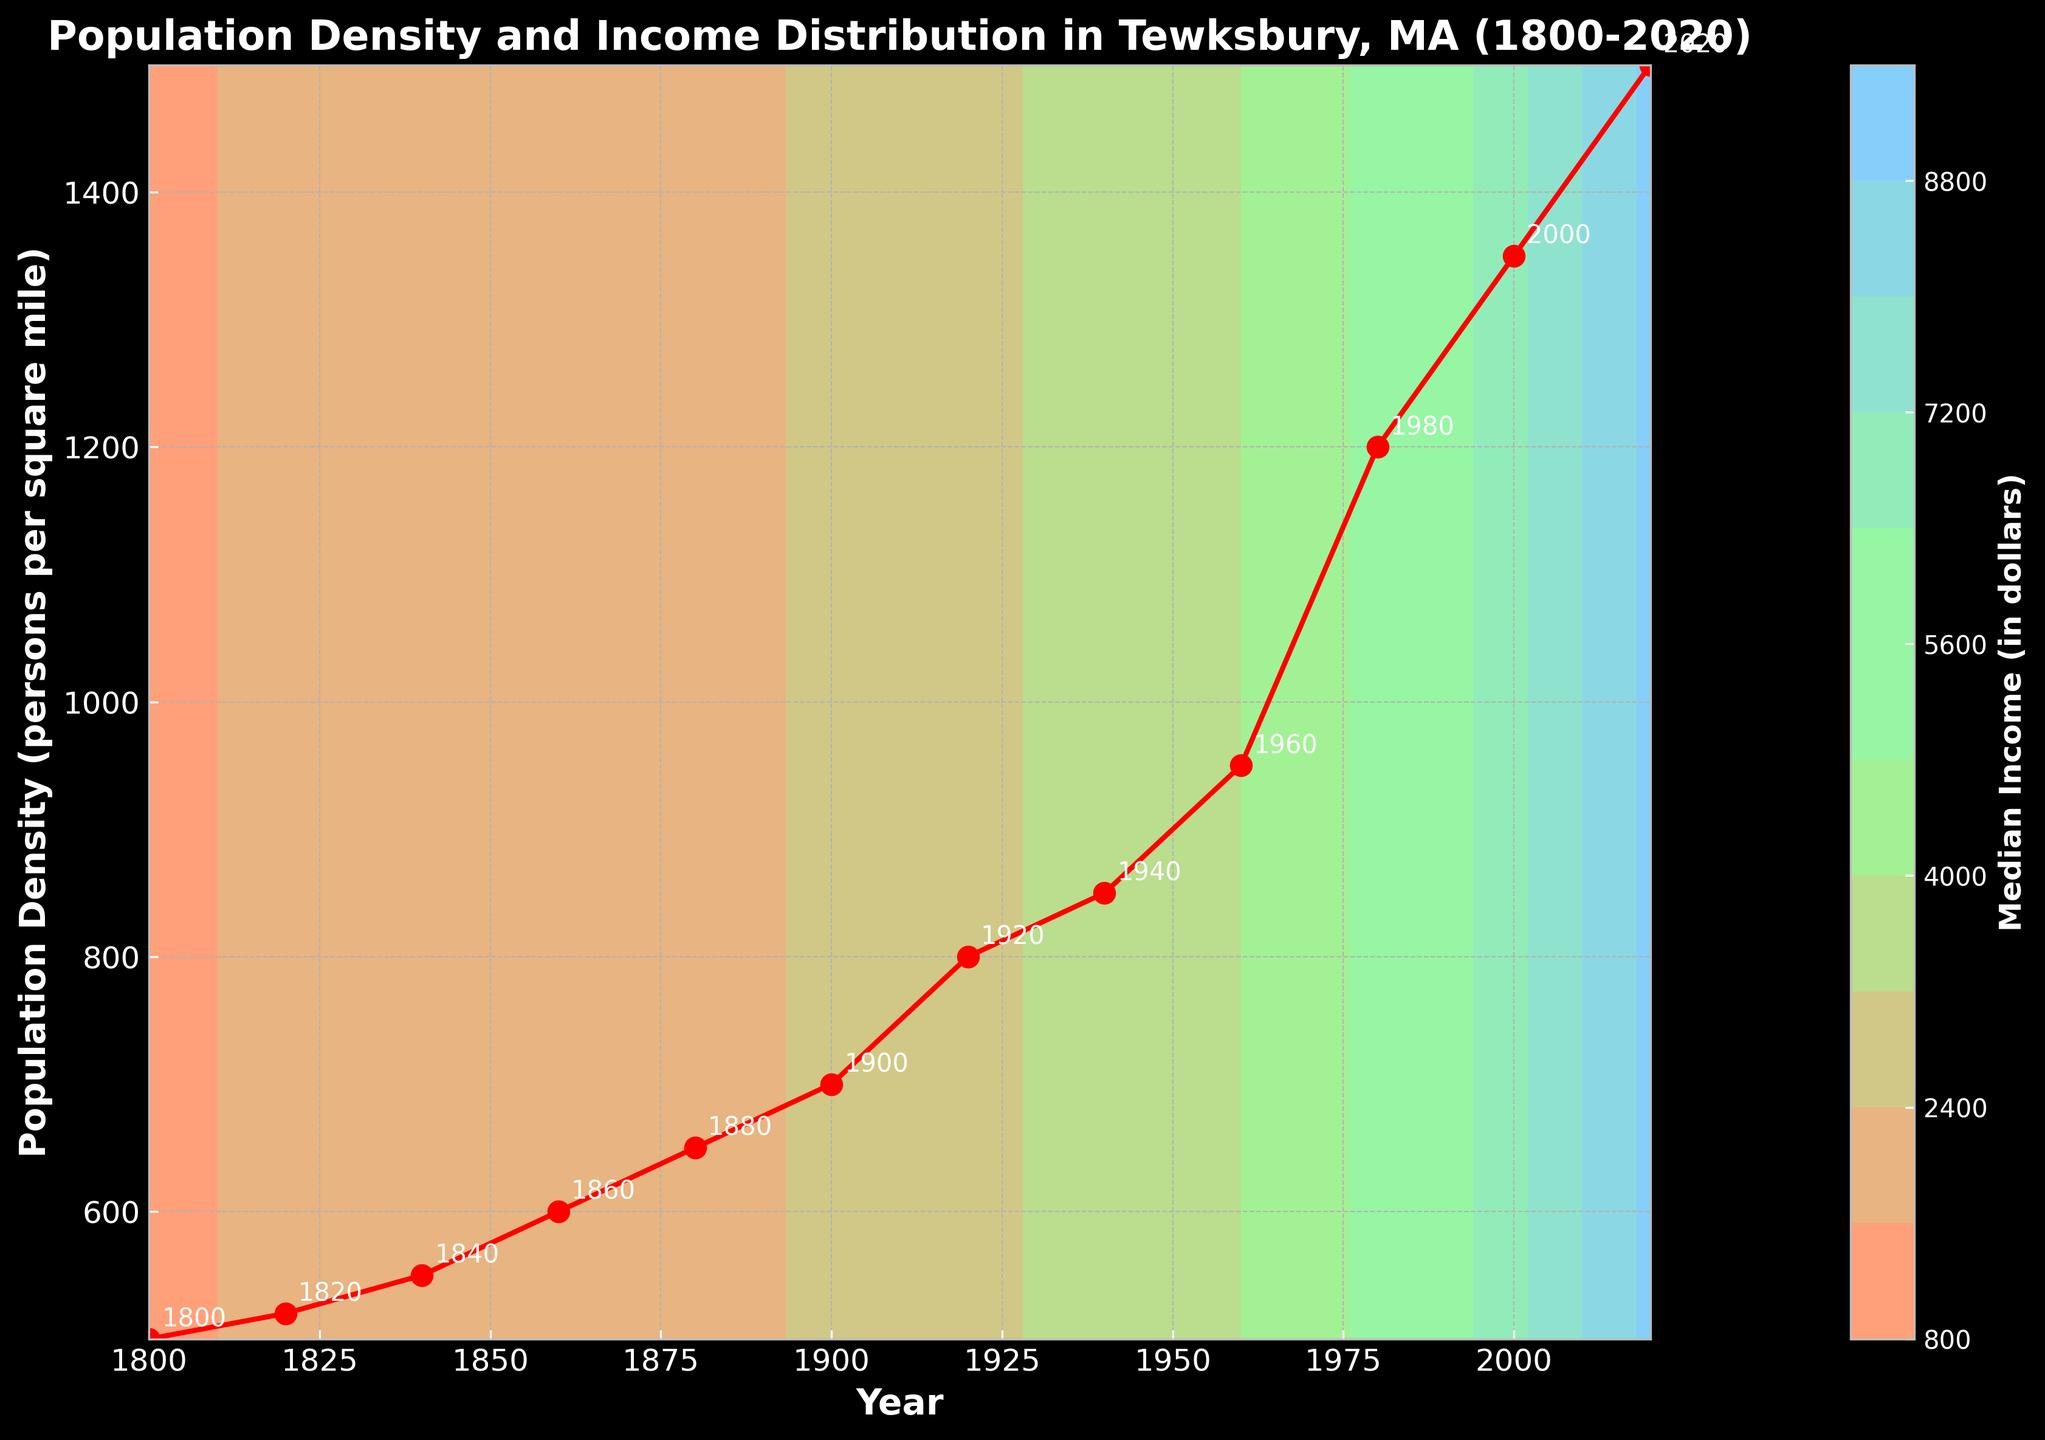What is the title of the plot? The title is text that is written prominently at the top of the plot. It provides a summary of what the entire figure is about. For this plot, it's written at the top and reads 'Population Density and Income Distribution in Tewksbury, MA (1800-2020)'.
Answer: Population Density and Income Distribution in Tewksbury, MA (1800-2020) What do the x-axis and y-axis represent? The x-axis is horizontal and has labels indicating the year, while the y-axis is vertical and represents population density in persons per square mile. These are indicated by the text along each axis.
Answer: Year (x-axis) and Population Density (persons per square mile) (y-axis) What is the range of years covered in the plot? The x-axis ranges from the year 1800 to 2020. This can be seen by looking at the leftmost and rightmost points along the horizontal axis.
Answer: 1800 to 2020 How does population density change from 1800 to 2020? Population density increases over time from 500 persons per square mile in 1800 to 1500 persons per square mile in 2020. This can be determined by following the red line from the leftmost point to the rightmost point.
Answer: It increases Which year has the highest population density? The highest population density can be found by looking at the highest point on the red line, which corresponds to the year 2020.
Answer: 2020 What general trend do you observe in median income over time according to the contour plot? The contour plot shows that median income generally increases over time, indicated by color changes from lighter to darker as you move from left to right along the x-axis.
Answer: It increases Around what population density does the median income start to exceed $5,000? The contour levels change color around the area where median income exceeds $5,000, which occurs at around 1200 persons per square mile in the year 1980.
Answer: Around 1200 persons per square mile (year 1980) In which year did the median income first exceed $2500? The median income first exceeds $2500 in the area marked by the corresponding color on the contour plot, which appears around the year 1900.
Answer: 1900 Comparing the years 1800 and 1920, in which year is the population density lower, and how much lower? The population density in 1800 is 500 persons per square mile and in 1920 is 800 persons per square mile. The difference is 800 - 500 = 300 persons per square mile.
Answer: 1800, by 300 persons per square mile What color represents a median income of around $3000? The color representing a median income of around $3000 can be observed in the contour plot for the year 1920 and corresponds to a particular shade shown in the legend. It's one of the lighter shades in the custom colormap.
Answer: A light green color 